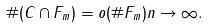<formula> <loc_0><loc_0><loc_500><loc_500>\# ( C \cap F _ { m } ) = o ( \# F _ { m } ) n \to \infty .</formula> 